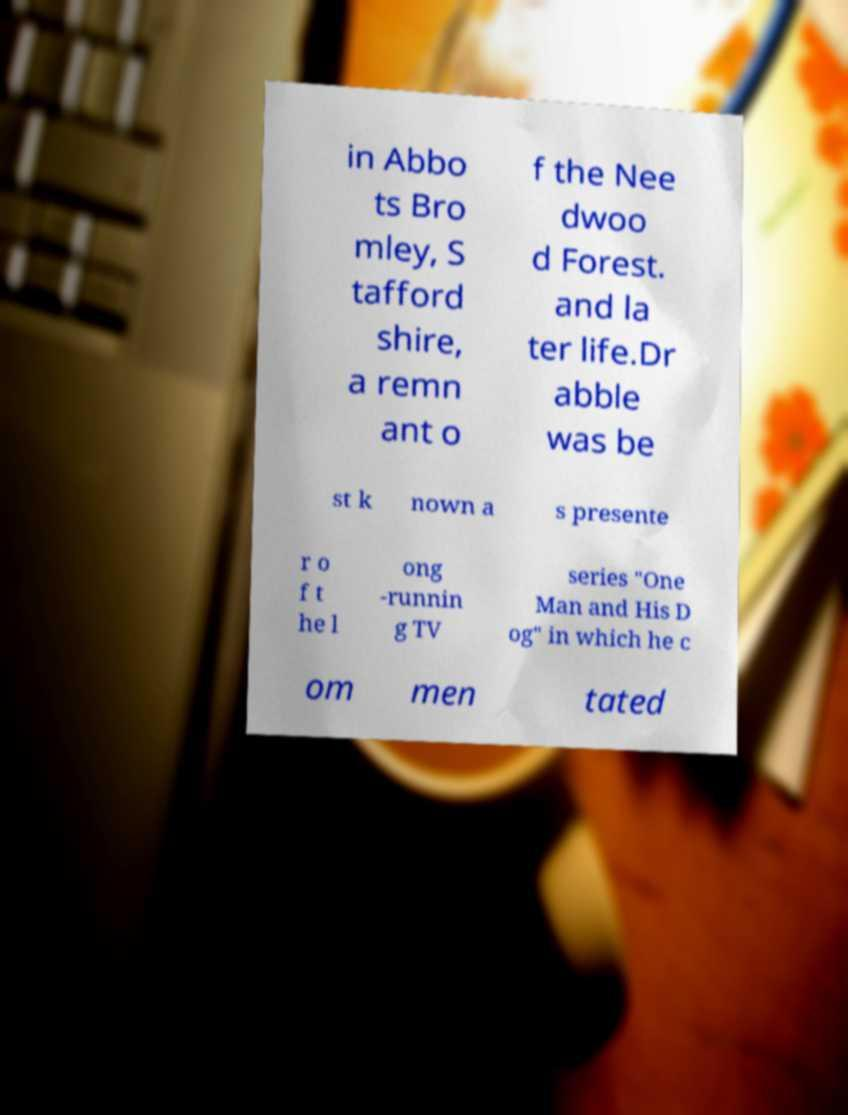Can you accurately transcribe the text from the provided image for me? in Abbo ts Bro mley, S tafford shire, a remn ant o f the Nee dwoo d Forest. and la ter life.Dr abble was be st k nown a s presente r o f t he l ong -runnin g TV series "One Man and His D og" in which he c om men tated 